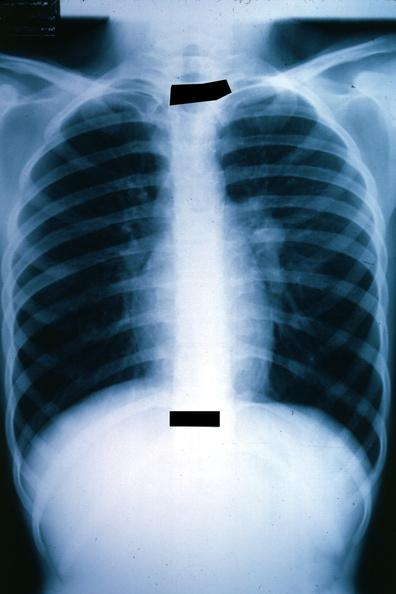s lung present?
Answer the question using a single word or phrase. Yes 